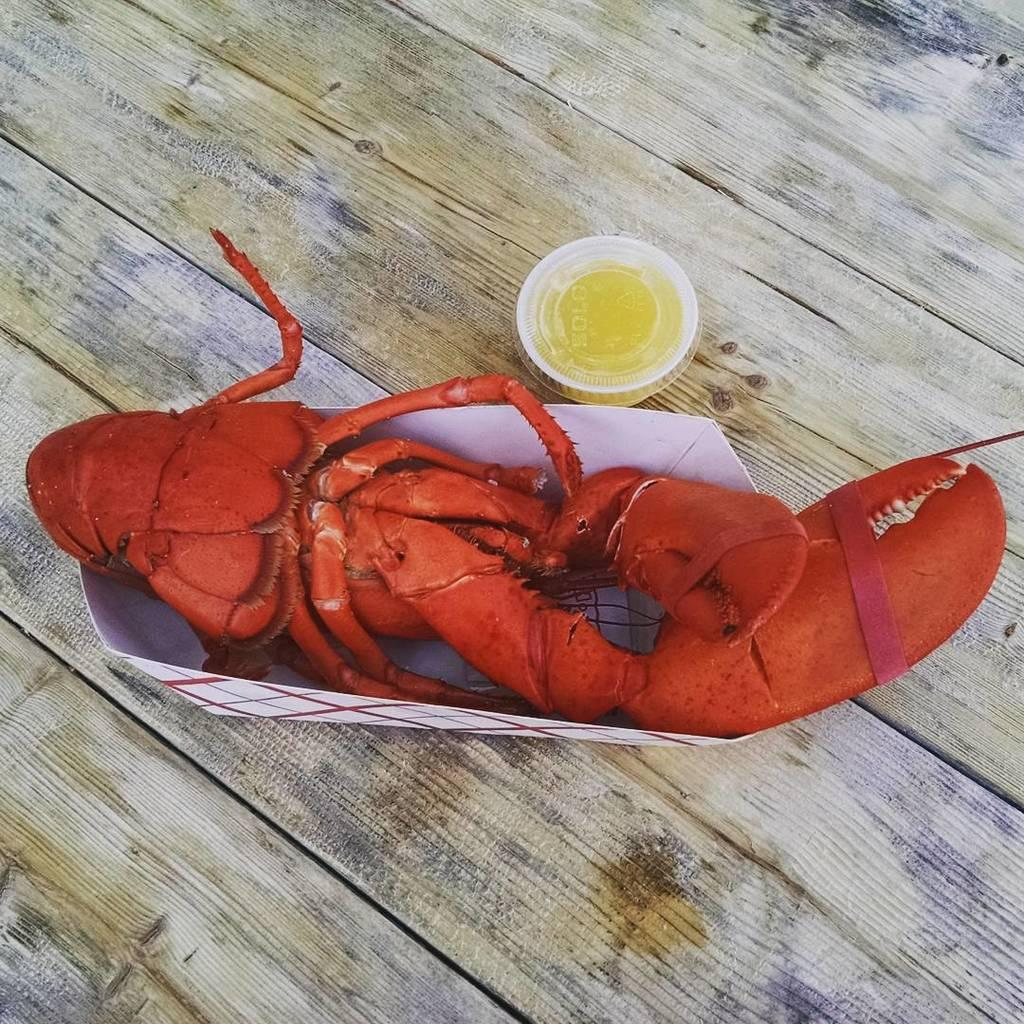What is the main piece of furniture in the image? There is a table in the image. What type of food is served in the paper bowl on the table? A crab is served in a paper bowl on the table. What is the packaging for the sauce on the table? There is a sauce packet on the table. How does the crab affect the person's cough in the image? There is no mention of a cough in the image. The image only shows a table with a crab served in a paper bowl and a sauce packet on the table. 